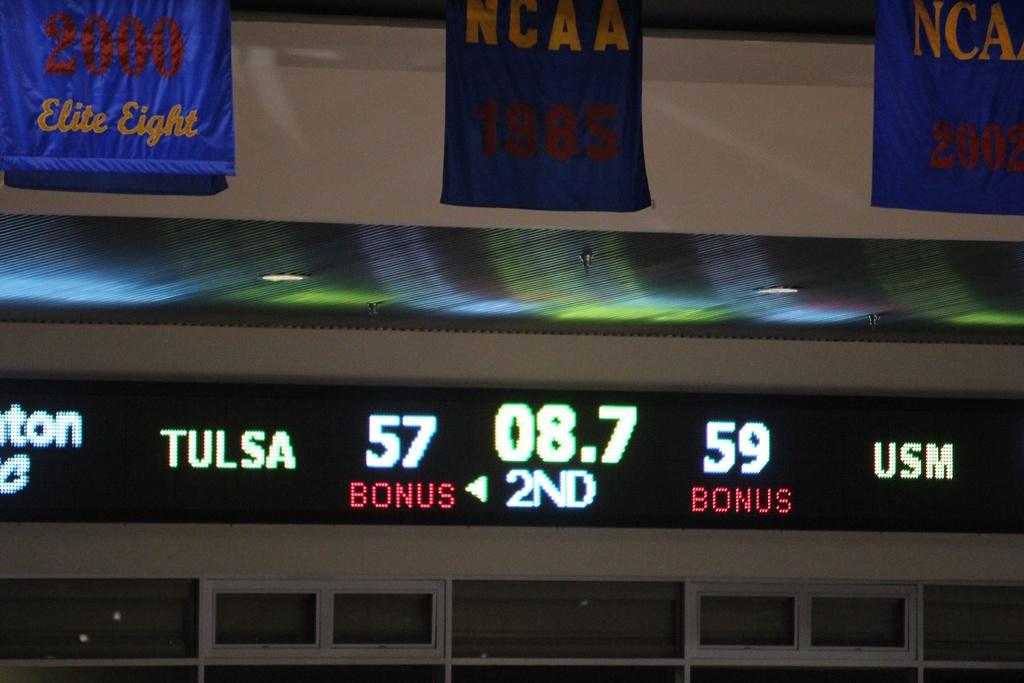What quarter are they in?
Keep it short and to the point. 2nd. 